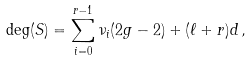<formula> <loc_0><loc_0><loc_500><loc_500>\deg ( S ) = \sum _ { i = 0 } ^ { r - 1 } \nu _ { i } ( 2 g - 2 ) + ( \ell + r ) d \, ,</formula> 